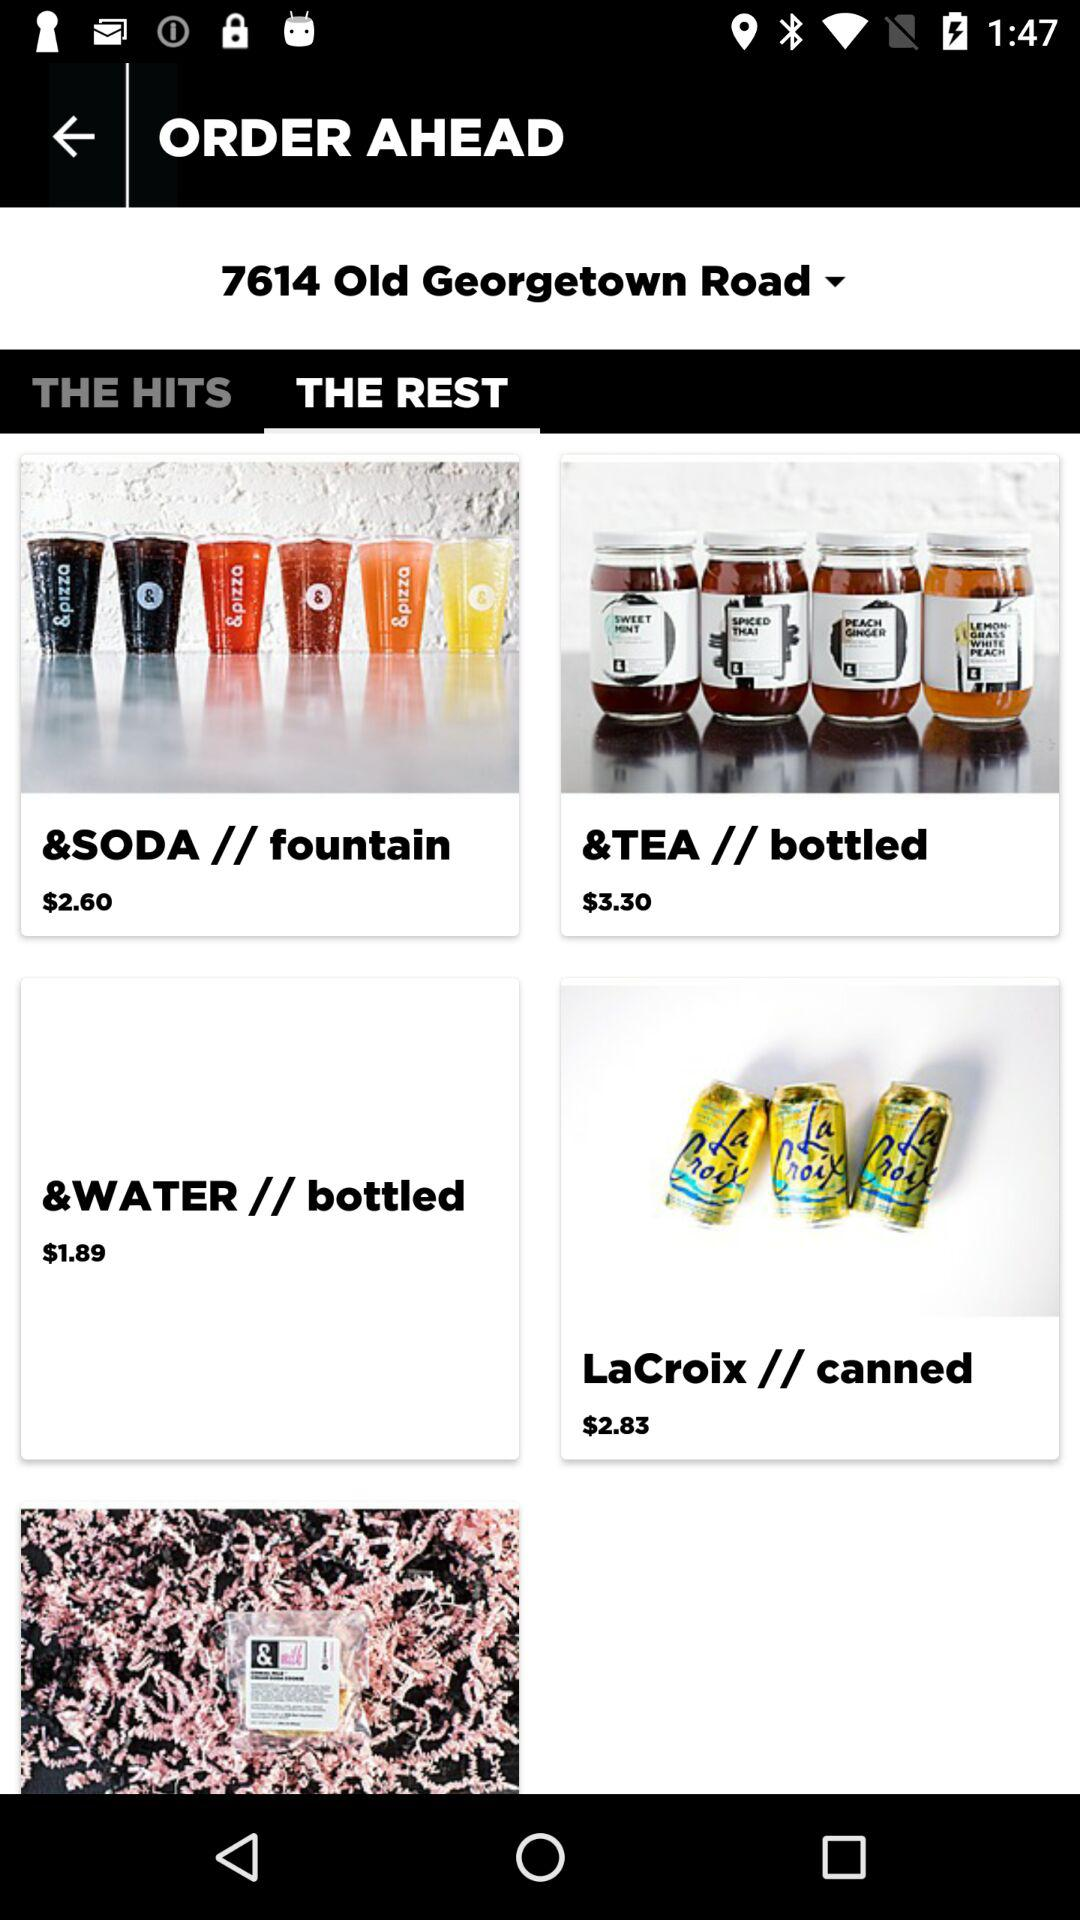Which tab is selected? The selected tab is "THE REST". 